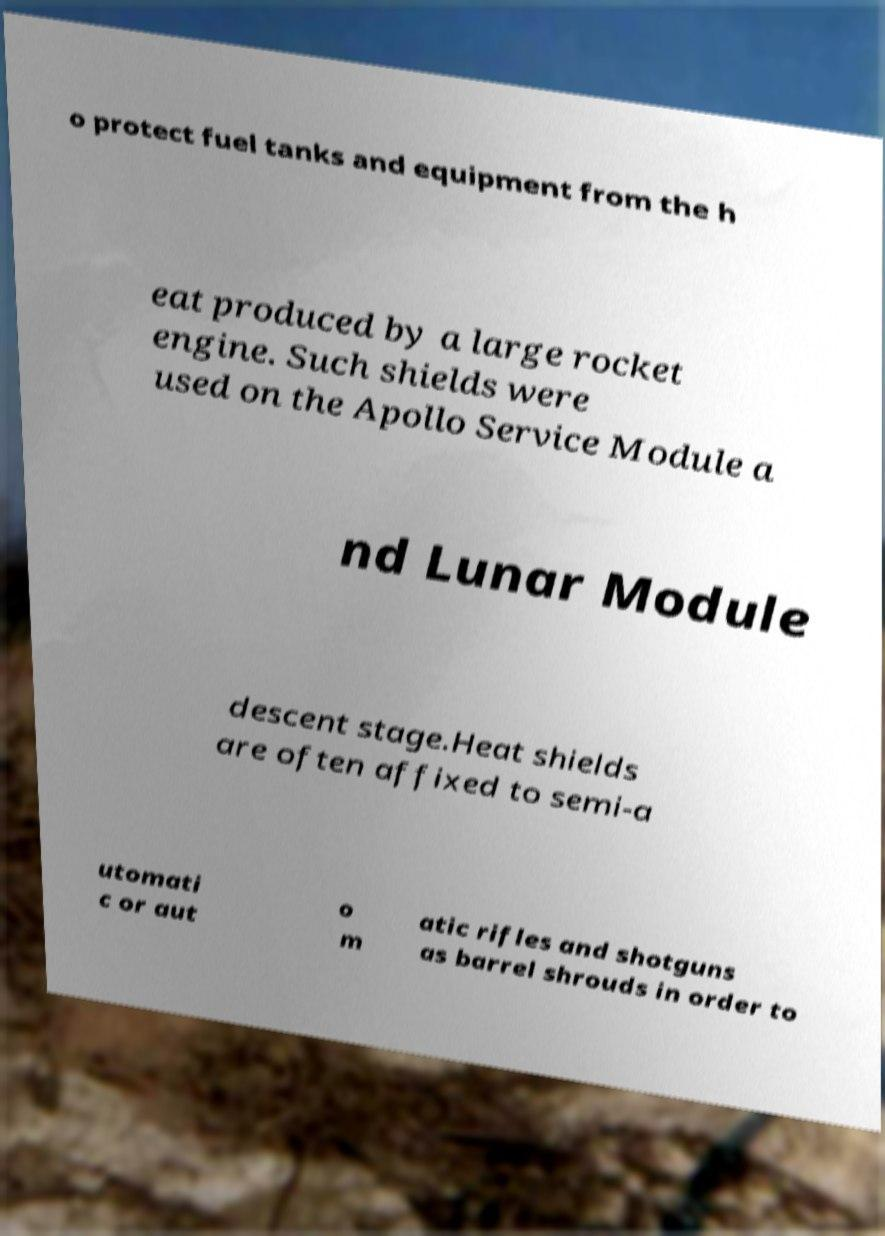What messages or text are displayed in this image? I need them in a readable, typed format. o protect fuel tanks and equipment from the h eat produced by a large rocket engine. Such shields were used on the Apollo Service Module a nd Lunar Module descent stage.Heat shields are often affixed to semi-a utomati c or aut o m atic rifles and shotguns as barrel shrouds in order to 